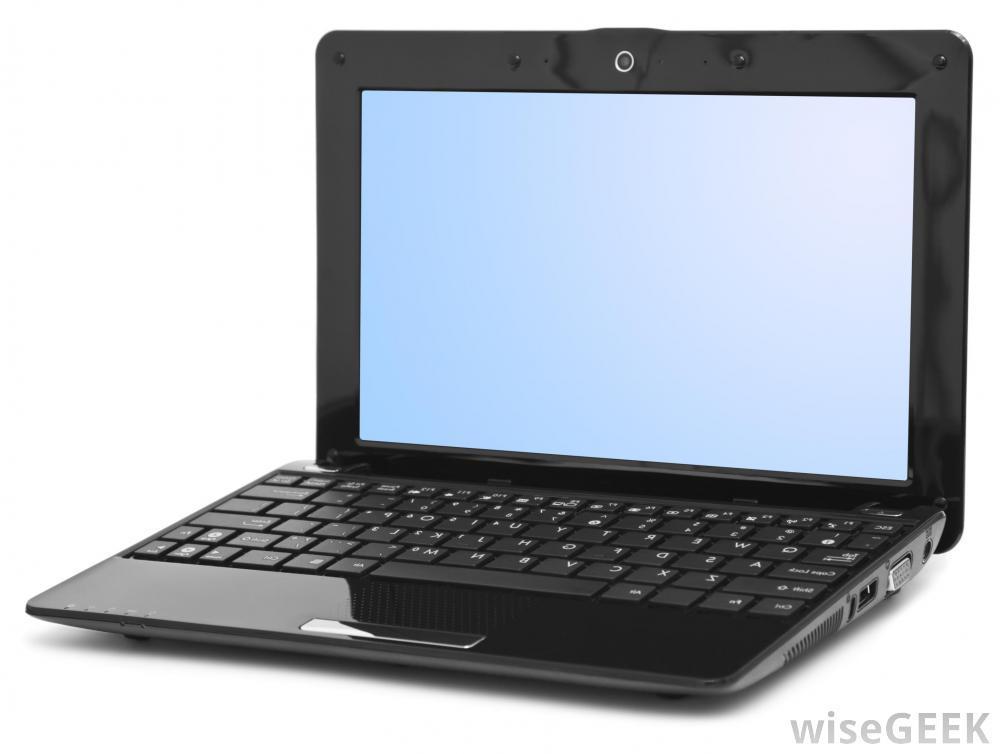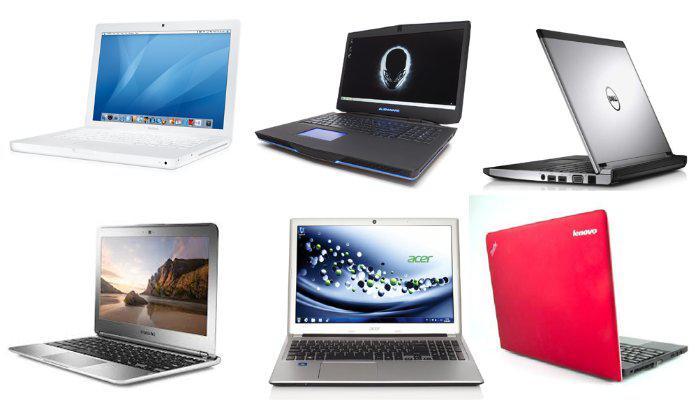The first image is the image on the left, the second image is the image on the right. Analyze the images presented: Is the assertion "One photo contains multiple laptops." valid? Answer yes or no. Yes. The first image is the image on the left, the second image is the image on the right. Considering the images on both sides, is "Each image contains exactly one laptop-type device." valid? Answer yes or no. No. 